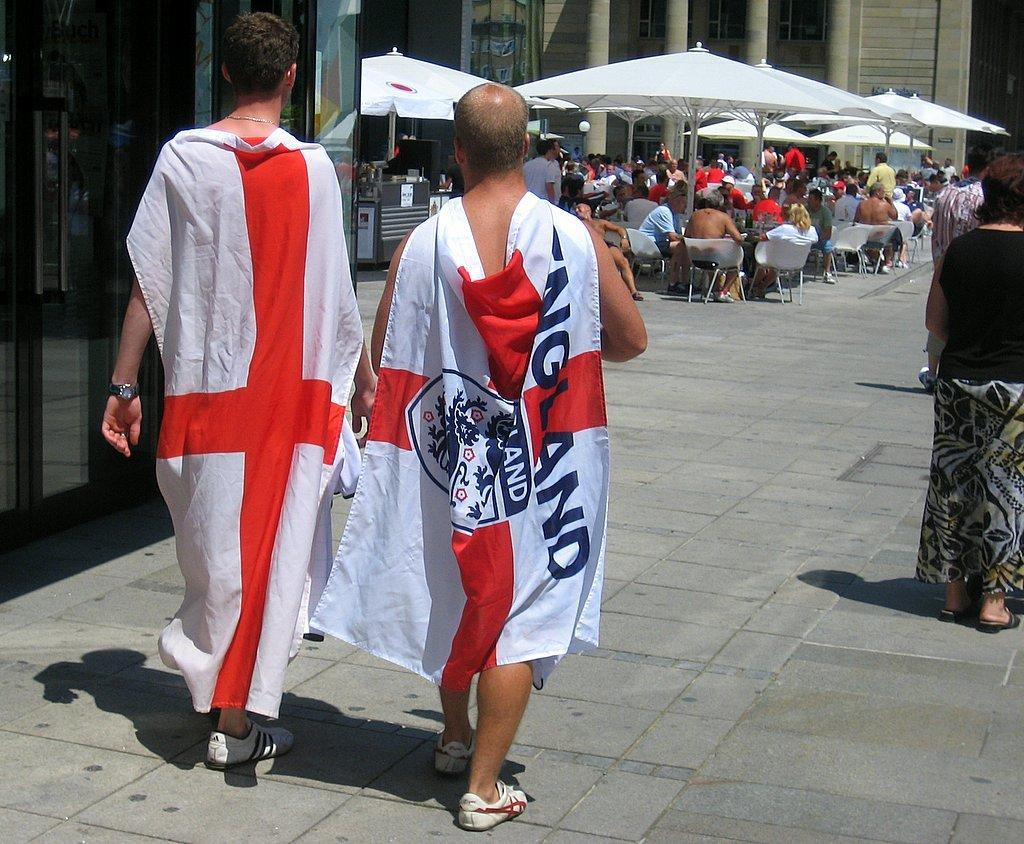<image>
Write a terse but informative summary of the picture. a flag that has an England logo on it 